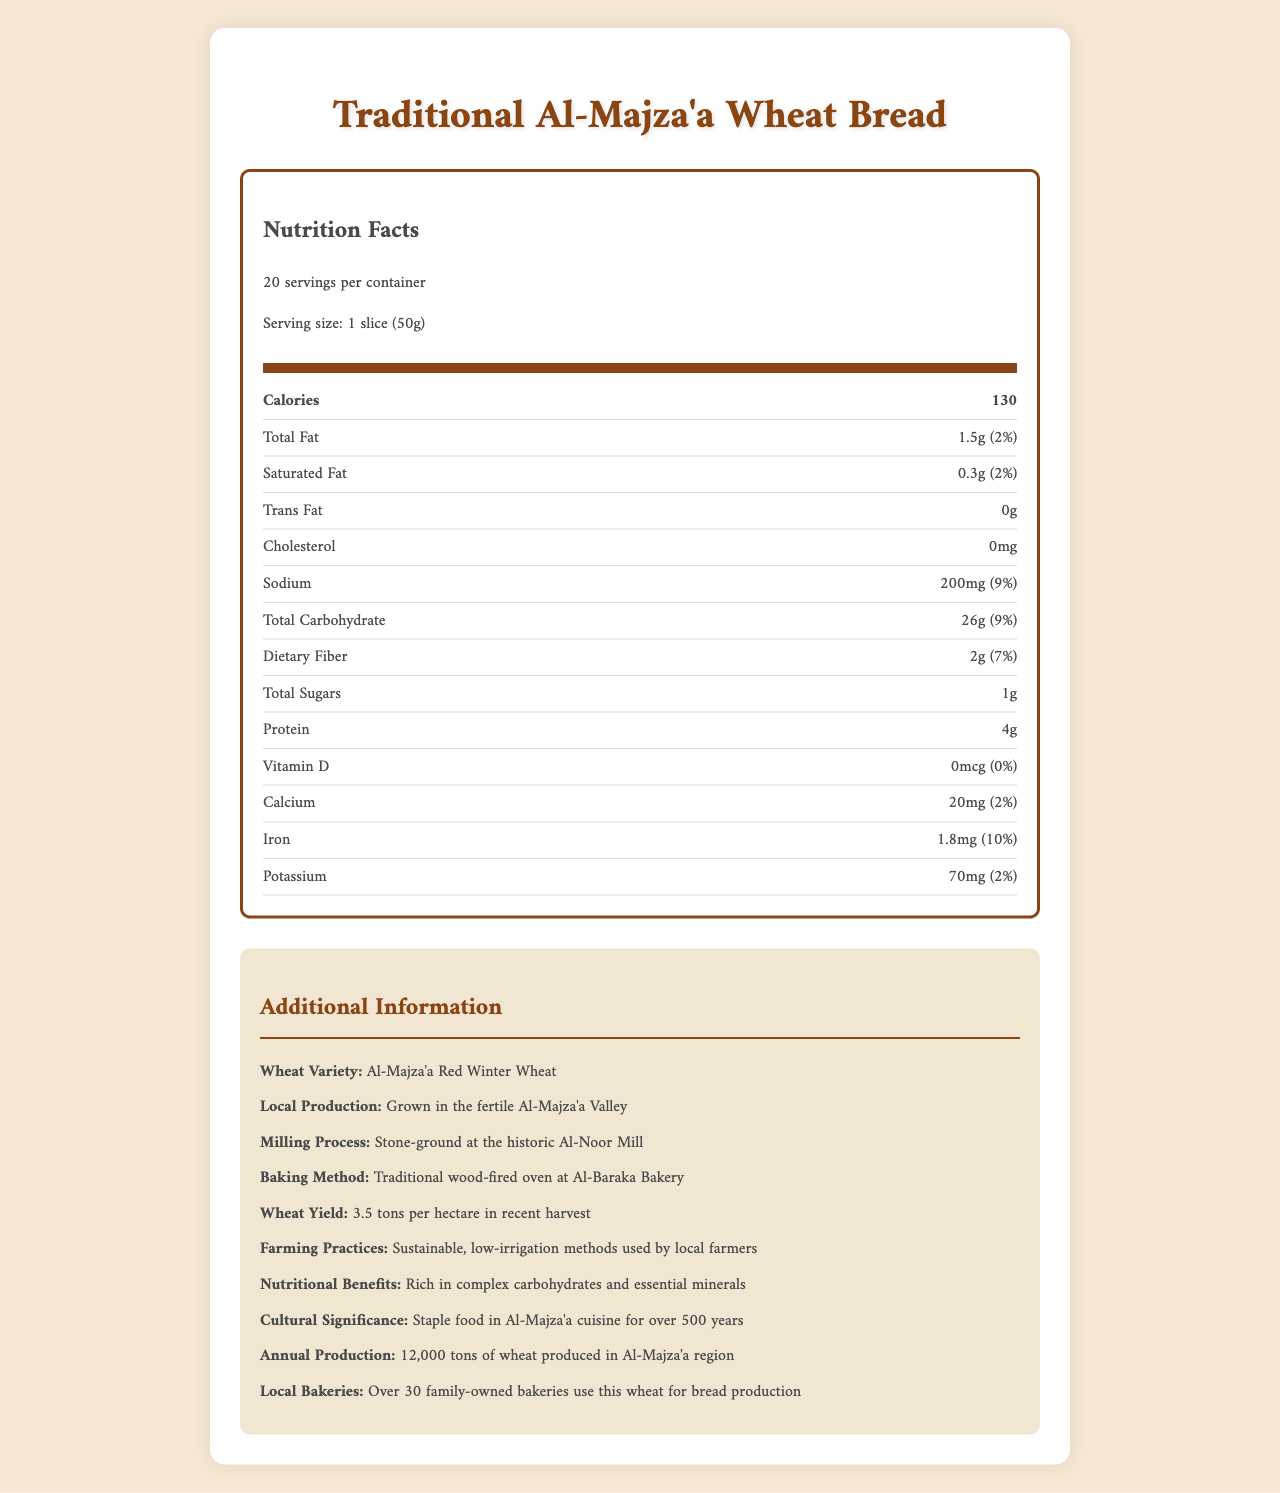How many calories does one serving of Traditional Al-Majza'a Wheat Bread contain? The document states that one serving (1 slice or 50g) contains 130 calories.
Answer: 130 What is the percentage of daily value for sodium in one serving? The document shows the sodium content as 200mg, which is 9% of the daily value.
Answer: 9% How much iron is in one serving of the bread? The document lists the iron content per serving as 1.8mg.
Answer: 1.8mg Identify the variety of wheat used in Traditional Al-Majza'a Wheat Bread. The additional information section notes that the wheat variety is Al-Majza'a Red Winter Wheat.
Answer: Al-Majza'a Red Winter Wheat What is the serving size of the bread? The document specifies the serving size as 1 slice (50g).
Answer: 1 slice (50g) Which of the following choices lists all family-owned bakeries that use this wheat?
A. 10
B. 20
C. 30 The additional info section states that over 30 family-owned bakeries use this wheat for bread production.
Answer: C What is the local production area for the wheat used in this bread? 
A. Al-Baraka
B. Al-Noor
C. Al-Majza'a Valley The wheat is grown in the fertile Al-Majza'a Valley as noted in the additional info section.
Answer: C Does the bread contain any trans fat? The document clearly states that there is 0g trans fat in one serving.
Answer: No Summarize the main idea of the document. The document outlines both the nutrition facts and supplementary details about the bread's ingredients, production area, and historical context.
Answer: The document provides nutritional information and additional local production details for Traditional Al-Majza'a Wheat Bread. It lists the various nutrients, their amounts, and daily values, and also includes information about the wheat's origin, farming practices, and cultural significance. What is the exact amount of potassium per serving in the bread? The document lists the potassium content per serving as 70mg.
Answer: 70mg Can you determine the exact number of calcium servings that would meet 100% of the daily value from the document? The document gives the calcium content per serving (20mg, 2% daily value), but it does not provide enough detail to calculate how many servings would meet 100% of the daily recommended value without additional context on the total daily value of calcium needed.
Answer: Cannot be determined How many grams of dietary fiber are in a serving? The document shows that there are 2g of dietary fiber per serving, which is 7% of the daily value.
Answer: 2g What is the main source of wheat used in production? As noted in the additional information section, the wheat is grown in the fertile Al-Majza'a Valley.
Answer: Grown in the fertile Al-Majza'a Valley Does the bread contain any cholesterol? The document states that there is 0mg cholesterol per serving.
Answer: No 